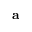Convert formula to latex. <formula><loc_0><loc_0><loc_500><loc_500>a</formula> 